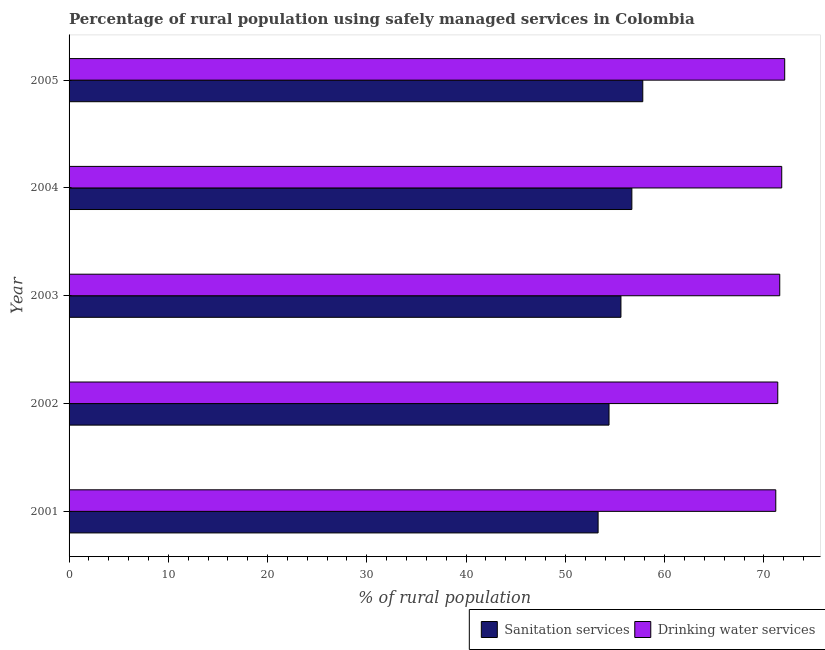Are the number of bars per tick equal to the number of legend labels?
Keep it short and to the point. Yes. Are the number of bars on each tick of the Y-axis equal?
Provide a succinct answer. Yes. How many bars are there on the 1st tick from the top?
Provide a succinct answer. 2. How many bars are there on the 4th tick from the bottom?
Make the answer very short. 2. What is the label of the 4th group of bars from the top?
Your response must be concise. 2002. In how many cases, is the number of bars for a given year not equal to the number of legend labels?
Provide a succinct answer. 0. What is the percentage of rural population who used sanitation services in 2005?
Give a very brief answer. 57.8. Across all years, what is the maximum percentage of rural population who used sanitation services?
Offer a very short reply. 57.8. Across all years, what is the minimum percentage of rural population who used drinking water services?
Your response must be concise. 71.2. In which year was the percentage of rural population who used drinking water services maximum?
Offer a very short reply. 2005. In which year was the percentage of rural population who used sanitation services minimum?
Make the answer very short. 2001. What is the total percentage of rural population who used sanitation services in the graph?
Keep it short and to the point. 277.8. What is the difference between the percentage of rural population who used sanitation services in 2003 and that in 2004?
Provide a short and direct response. -1.1. What is the difference between the percentage of rural population who used sanitation services in 2004 and the percentage of rural population who used drinking water services in 2005?
Your answer should be compact. -15.4. What is the average percentage of rural population who used drinking water services per year?
Provide a succinct answer. 71.62. In the year 2002, what is the difference between the percentage of rural population who used drinking water services and percentage of rural population who used sanitation services?
Your response must be concise. 17. What is the difference between the highest and the lowest percentage of rural population who used drinking water services?
Your response must be concise. 0.9. In how many years, is the percentage of rural population who used drinking water services greater than the average percentage of rural population who used drinking water services taken over all years?
Provide a succinct answer. 2. Is the sum of the percentage of rural population who used sanitation services in 2001 and 2003 greater than the maximum percentage of rural population who used drinking water services across all years?
Your response must be concise. Yes. What does the 2nd bar from the top in 2002 represents?
Your answer should be compact. Sanitation services. What does the 2nd bar from the bottom in 2004 represents?
Your answer should be compact. Drinking water services. How many bars are there?
Offer a terse response. 10. Are all the bars in the graph horizontal?
Your answer should be compact. Yes. Are the values on the major ticks of X-axis written in scientific E-notation?
Make the answer very short. No. Does the graph contain any zero values?
Give a very brief answer. No. Does the graph contain grids?
Your answer should be compact. No. What is the title of the graph?
Your response must be concise. Percentage of rural population using safely managed services in Colombia. Does "Excluding technical cooperation" appear as one of the legend labels in the graph?
Your answer should be very brief. No. What is the label or title of the X-axis?
Keep it short and to the point. % of rural population. What is the % of rural population in Sanitation services in 2001?
Ensure brevity in your answer.  53.3. What is the % of rural population in Drinking water services in 2001?
Give a very brief answer. 71.2. What is the % of rural population in Sanitation services in 2002?
Offer a very short reply. 54.4. What is the % of rural population of Drinking water services in 2002?
Offer a terse response. 71.4. What is the % of rural population of Sanitation services in 2003?
Provide a short and direct response. 55.6. What is the % of rural population of Drinking water services in 2003?
Provide a short and direct response. 71.6. What is the % of rural population of Sanitation services in 2004?
Your response must be concise. 56.7. What is the % of rural population in Drinking water services in 2004?
Make the answer very short. 71.8. What is the % of rural population in Sanitation services in 2005?
Your answer should be very brief. 57.8. What is the % of rural population of Drinking water services in 2005?
Give a very brief answer. 72.1. Across all years, what is the maximum % of rural population in Sanitation services?
Offer a very short reply. 57.8. Across all years, what is the maximum % of rural population of Drinking water services?
Your answer should be very brief. 72.1. Across all years, what is the minimum % of rural population of Sanitation services?
Provide a short and direct response. 53.3. Across all years, what is the minimum % of rural population in Drinking water services?
Give a very brief answer. 71.2. What is the total % of rural population of Sanitation services in the graph?
Offer a terse response. 277.8. What is the total % of rural population of Drinking water services in the graph?
Provide a succinct answer. 358.1. What is the difference between the % of rural population in Sanitation services in 2001 and that in 2004?
Your response must be concise. -3.4. What is the difference between the % of rural population of Drinking water services in 2001 and that in 2004?
Your answer should be very brief. -0.6. What is the difference between the % of rural population of Sanitation services in 2002 and that in 2003?
Your answer should be compact. -1.2. What is the difference between the % of rural population of Sanitation services in 2002 and that in 2004?
Offer a terse response. -2.3. What is the difference between the % of rural population in Drinking water services in 2002 and that in 2004?
Ensure brevity in your answer.  -0.4. What is the difference between the % of rural population in Sanitation services in 2002 and that in 2005?
Offer a very short reply. -3.4. What is the difference between the % of rural population in Drinking water services in 2003 and that in 2004?
Your answer should be very brief. -0.2. What is the difference between the % of rural population in Sanitation services in 2004 and that in 2005?
Offer a very short reply. -1.1. What is the difference between the % of rural population of Sanitation services in 2001 and the % of rural population of Drinking water services in 2002?
Your response must be concise. -18.1. What is the difference between the % of rural population of Sanitation services in 2001 and the % of rural population of Drinking water services in 2003?
Your answer should be compact. -18.3. What is the difference between the % of rural population in Sanitation services in 2001 and the % of rural population in Drinking water services in 2004?
Ensure brevity in your answer.  -18.5. What is the difference between the % of rural population of Sanitation services in 2001 and the % of rural population of Drinking water services in 2005?
Your answer should be compact. -18.8. What is the difference between the % of rural population of Sanitation services in 2002 and the % of rural population of Drinking water services in 2003?
Provide a short and direct response. -17.2. What is the difference between the % of rural population of Sanitation services in 2002 and the % of rural population of Drinking water services in 2004?
Your answer should be compact. -17.4. What is the difference between the % of rural population of Sanitation services in 2002 and the % of rural population of Drinking water services in 2005?
Your answer should be compact. -17.7. What is the difference between the % of rural population of Sanitation services in 2003 and the % of rural population of Drinking water services in 2004?
Make the answer very short. -16.2. What is the difference between the % of rural population in Sanitation services in 2003 and the % of rural population in Drinking water services in 2005?
Offer a terse response. -16.5. What is the difference between the % of rural population of Sanitation services in 2004 and the % of rural population of Drinking water services in 2005?
Provide a short and direct response. -15.4. What is the average % of rural population of Sanitation services per year?
Your answer should be very brief. 55.56. What is the average % of rural population in Drinking water services per year?
Ensure brevity in your answer.  71.62. In the year 2001, what is the difference between the % of rural population of Sanitation services and % of rural population of Drinking water services?
Offer a very short reply. -17.9. In the year 2004, what is the difference between the % of rural population of Sanitation services and % of rural population of Drinking water services?
Ensure brevity in your answer.  -15.1. In the year 2005, what is the difference between the % of rural population of Sanitation services and % of rural population of Drinking water services?
Your response must be concise. -14.3. What is the ratio of the % of rural population of Sanitation services in 2001 to that in 2002?
Offer a very short reply. 0.98. What is the ratio of the % of rural population of Sanitation services in 2001 to that in 2003?
Give a very brief answer. 0.96. What is the ratio of the % of rural population of Sanitation services in 2001 to that in 2005?
Keep it short and to the point. 0.92. What is the ratio of the % of rural population of Drinking water services in 2001 to that in 2005?
Offer a very short reply. 0.99. What is the ratio of the % of rural population in Sanitation services in 2002 to that in 2003?
Provide a short and direct response. 0.98. What is the ratio of the % of rural population of Sanitation services in 2002 to that in 2004?
Your answer should be very brief. 0.96. What is the ratio of the % of rural population of Drinking water services in 2002 to that in 2004?
Provide a short and direct response. 0.99. What is the ratio of the % of rural population in Drinking water services in 2002 to that in 2005?
Provide a short and direct response. 0.99. What is the ratio of the % of rural population in Sanitation services in 2003 to that in 2004?
Make the answer very short. 0.98. What is the ratio of the % of rural population of Drinking water services in 2003 to that in 2004?
Your response must be concise. 1. What is the ratio of the % of rural population in Sanitation services in 2003 to that in 2005?
Your answer should be compact. 0.96. What is the ratio of the % of rural population of Sanitation services in 2004 to that in 2005?
Your response must be concise. 0.98. What is the difference between the highest and the second highest % of rural population of Sanitation services?
Provide a short and direct response. 1.1. What is the difference between the highest and the lowest % of rural population of Drinking water services?
Provide a succinct answer. 0.9. 